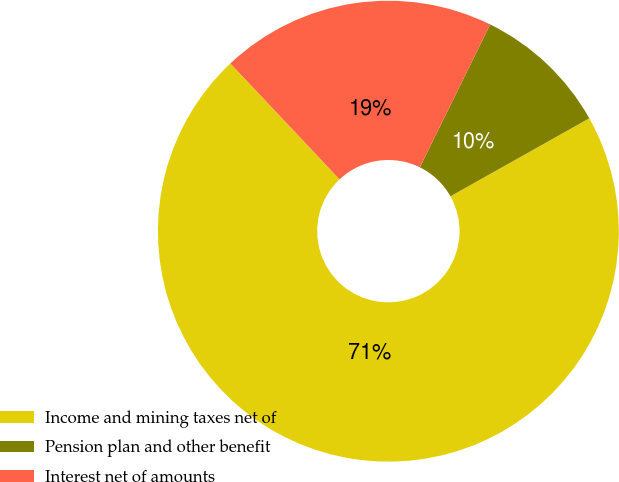Convert chart to OTSL. <chart><loc_0><loc_0><loc_500><loc_500><pie_chart><fcel>Income and mining taxes net of<fcel>Pension plan and other benefit<fcel>Interest net of amounts<nl><fcel>71.12%<fcel>9.57%<fcel>19.31%<nl></chart> 